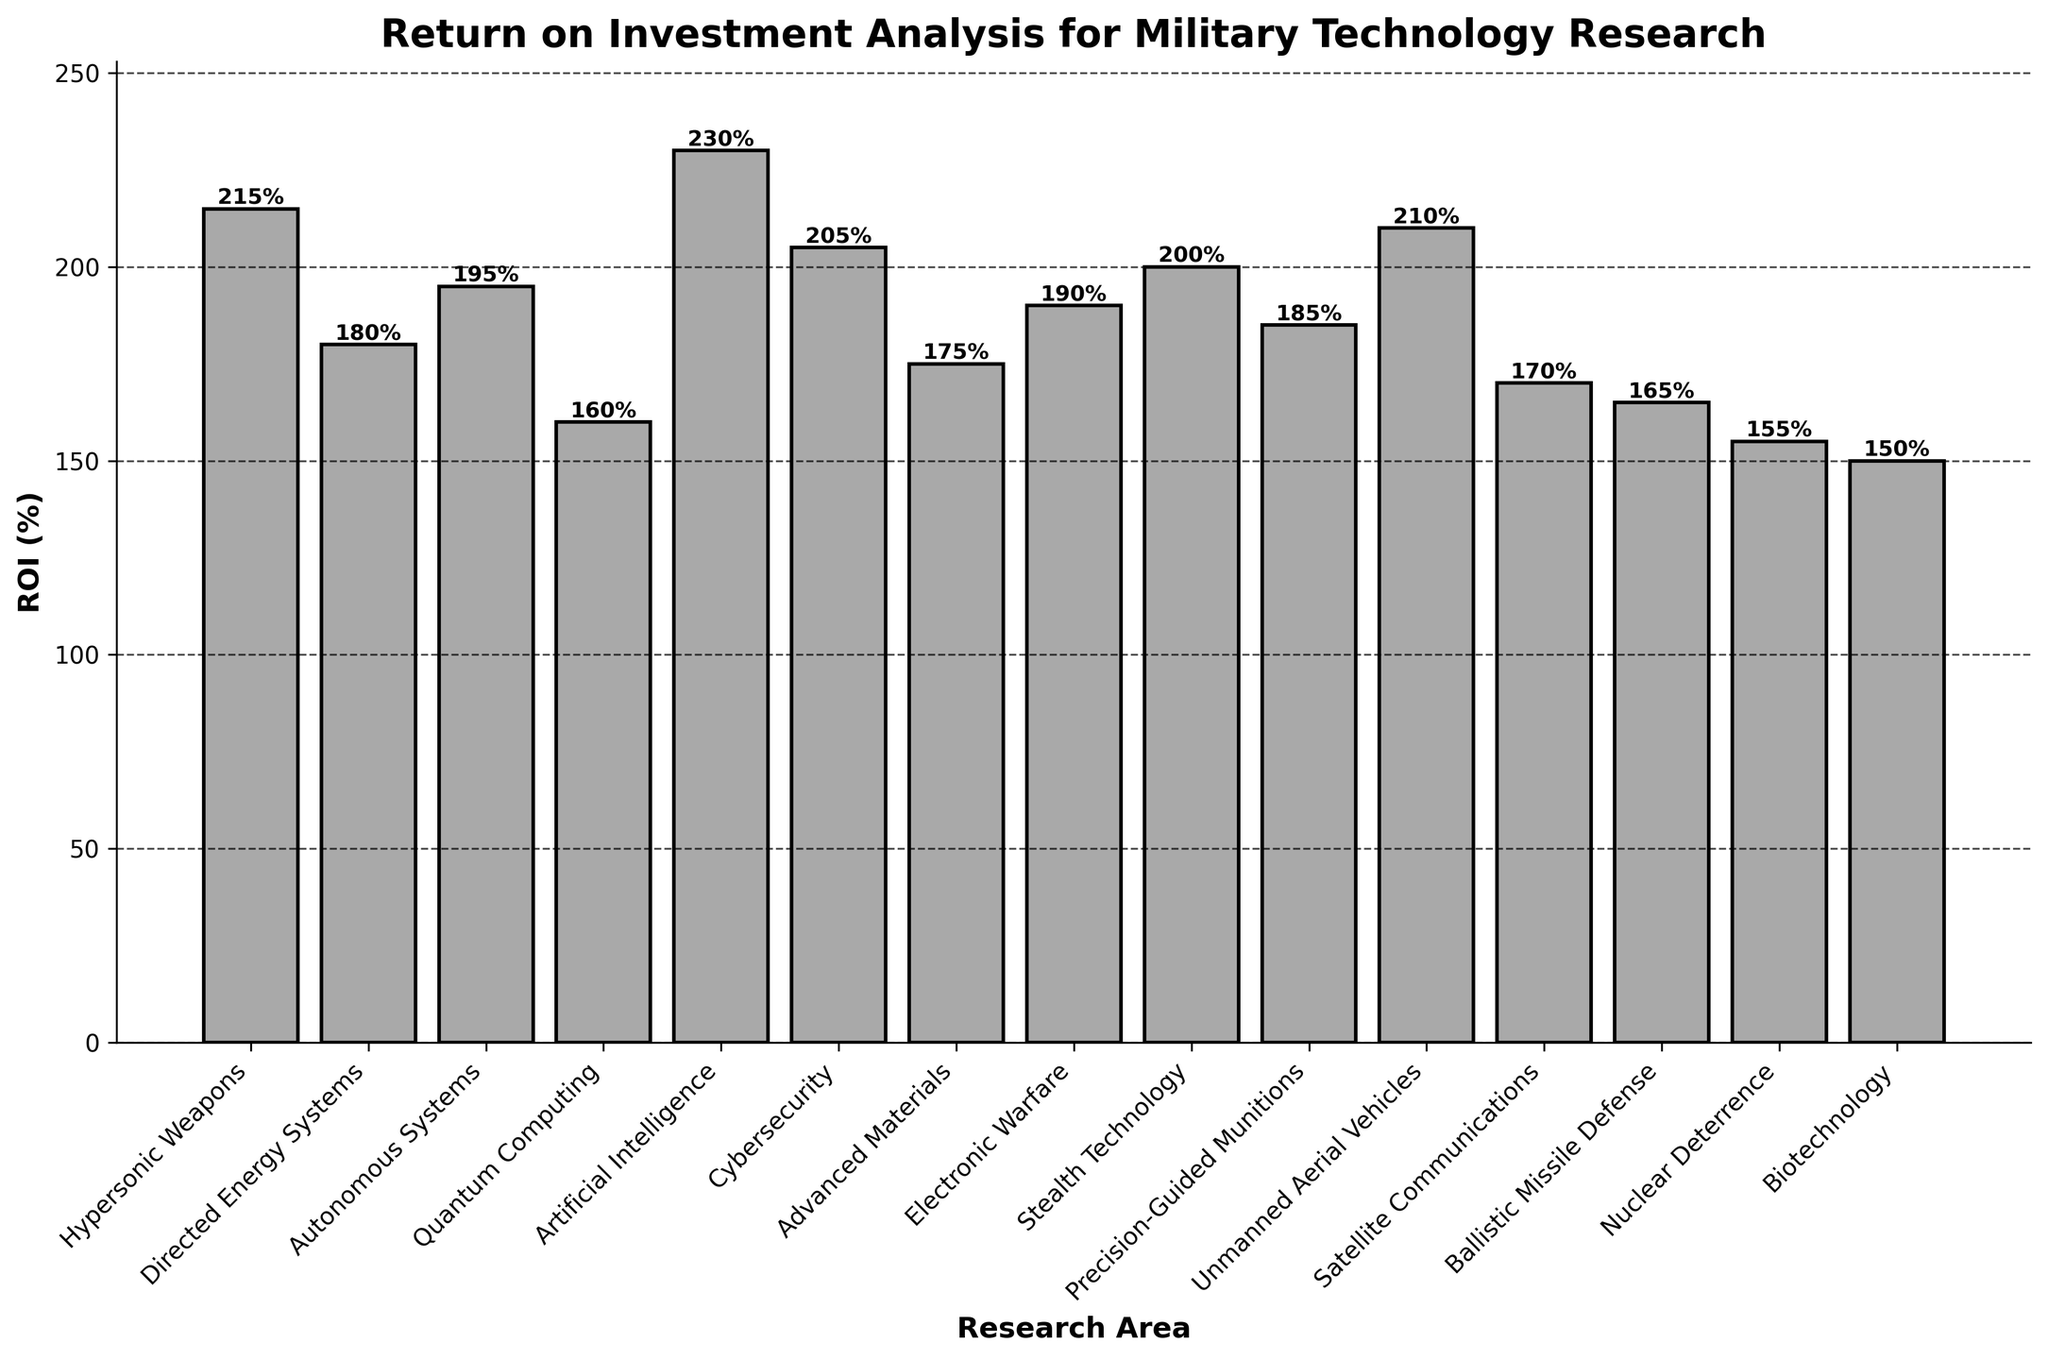What is the research area with the highest ROI? The bar chart shows the different research areas on the x-axis and the corresponding ROI on the y-axis. By observing the height of each bar, we see that "Artificial Intelligence" has the tallest bar, representing the highest ROI.
Answer: Artificial Intelligence How much higher is the ROI of Artificial Intelligence compared to Quantum Computing? First, identify the ROI values from the chart: Artificial Intelligence has 230% and Quantum Computing has 160%. Subtract the ROI of Quantum Computing from the ROI of Artificial Intelligence: 230% - 160% = 70%.
Answer: 70% Which research areas have an ROI greater than 200%? Check the bar heights that surpass the 200% mark. From the figure, the areas are "Hypersonic Weapons," "Artificial Intelligence," "Cybersecurity," and "Unmanned Aerial Vehicles."
Answer: Hypersonic Weapons, Artificial Intelligence, Cybersecurity, Unmanned Aerial Vehicles What is the difference in ROI between the Stealth Technology and Directed Energy Systems? From the bar chart, identify the ROI values: Stealth Technology has 200% and Directed Energy Systems has 180%. Subtract the ROI of Directed Energy Systems from the ROI of Stealth Technology: 200% - 180% = 20%.
Answer: 20% How many research areas have an ROI below 170%? Identify the bars with ROI values below 170%. These areas are "Biotechnology" (150%), "Nuclear Deterrence" (155%), "Ballistic Missile Defense" (165%), and "Quantum Computing" (160%). There are 4 such research areas.
Answer: 4 Which research area has the smallest ROI? By looking at the shortest bar on the chart, we see "Biotechnology" has the smallest ROI.
Answer: Biotechnology What is the average ROI of the top three research areas? Identify the top three ROI values: Artificial Intelligence (230%), Hypersonic Weapons (215%), and Unmanned Aerial Vehicles (210%). Sum these values: 230% + 215% + 210% = 655%. Divide by three to get the average: 655% / 3 ≈ 218.3%.
Answer: 218.3% What is the median ROI of all the research areas? List the ROI values in ascending order: 150%, 155%, 160%, 165%, 170%, 175%, 180%, 185%, 190%, 195%, 200%, 205%, 210%, 215%, 230%. The median value is the middle value in this ordered list, which is the 8th value: 185%.
Answer: 185% Which research areas have an ROI between 185% and 200%? Identify the bars within this range of heights. These research areas are "Electronic Warfare" (190%), "Autonomous Systems" (195%), "Stealth Technology" (200%), and "Precision-Guided Munitions" (185%).
Answer: Electronic Warfare, Autonomous Systems, Stealth Technology, Precision-Guided Munitions 